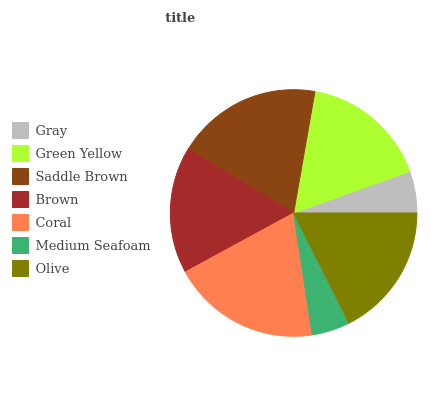Is Medium Seafoam the minimum?
Answer yes or no. Yes. Is Coral the maximum?
Answer yes or no. Yes. Is Green Yellow the minimum?
Answer yes or no. No. Is Green Yellow the maximum?
Answer yes or no. No. Is Green Yellow greater than Gray?
Answer yes or no. Yes. Is Gray less than Green Yellow?
Answer yes or no. Yes. Is Gray greater than Green Yellow?
Answer yes or no. No. Is Green Yellow less than Gray?
Answer yes or no. No. Is Green Yellow the high median?
Answer yes or no. Yes. Is Green Yellow the low median?
Answer yes or no. Yes. Is Saddle Brown the high median?
Answer yes or no. No. Is Saddle Brown the low median?
Answer yes or no. No. 